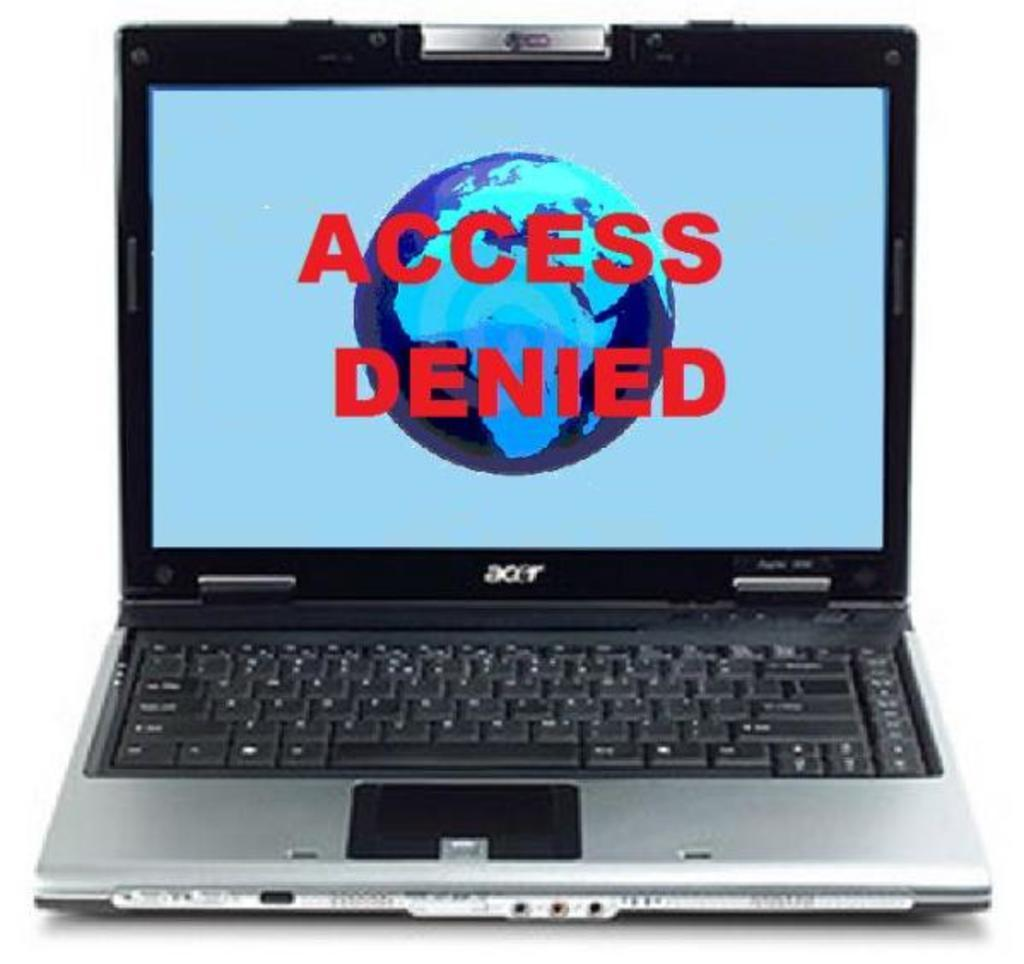<image>
Summarize the visual content of the image. An acer laptop is open with the screen displaying "Access denied." 